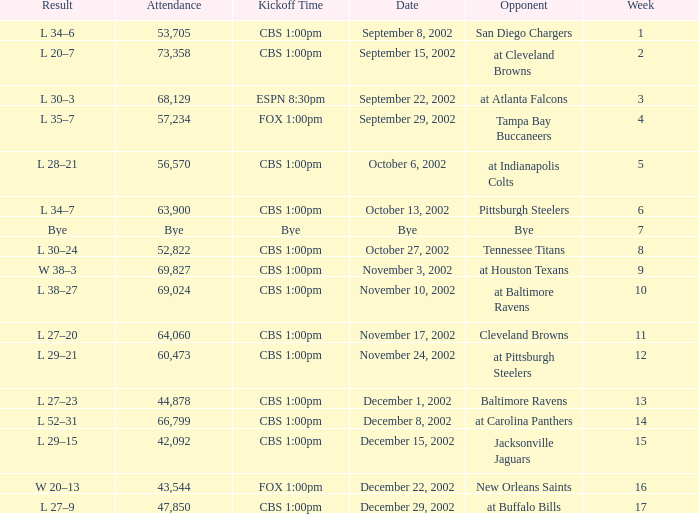What is the kickoff time on November 10, 2002? CBS 1:00pm. 